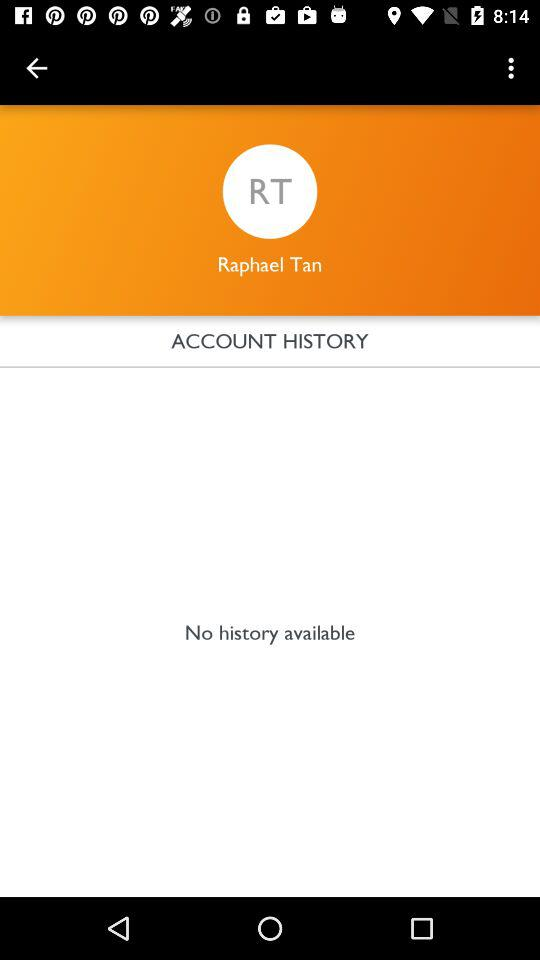Is there any history available? There is no history available. 